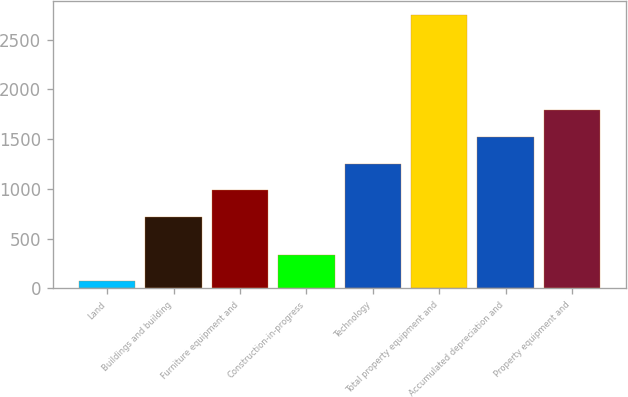Convert chart. <chart><loc_0><loc_0><loc_500><loc_500><bar_chart><fcel>Land<fcel>Buildings and building<fcel>Furniture equipment and<fcel>Construction-in-progress<fcel>Technology<fcel>Total property equipment and<fcel>Accumulated depreciation and<fcel>Property equipment and<nl><fcel>71<fcel>719<fcel>986.8<fcel>338.8<fcel>1254.6<fcel>2749<fcel>1522.4<fcel>1790.2<nl></chart> 